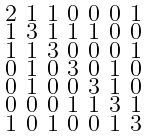Convert formula to latex. <formula><loc_0><loc_0><loc_500><loc_500>\begin{smallmatrix} 2 & 1 & 1 & 0 & 0 & 0 & 1 \\ 1 & 3 & 1 & 1 & 1 & 0 & 0 \\ 1 & 1 & 3 & 0 & 0 & 0 & 1 \\ 0 & 1 & 0 & 3 & 0 & 1 & 0 \\ 0 & 1 & 0 & 0 & 3 & 1 & 0 \\ 0 & 0 & 0 & 1 & 1 & 3 & 1 \\ 1 & 0 & 1 & 0 & 0 & 1 & 3 \end{smallmatrix}</formula> 